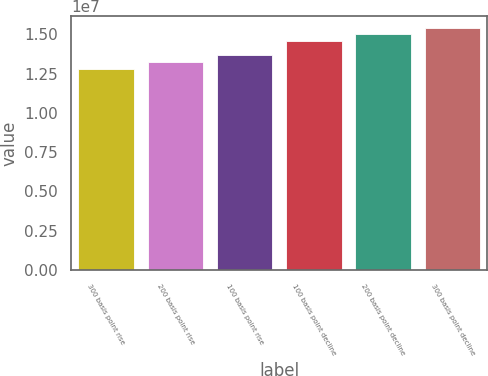<chart> <loc_0><loc_0><loc_500><loc_500><bar_chart><fcel>300 basis point rise<fcel>200 basis point rise<fcel>100 basis point rise<fcel>100 basis point decline<fcel>200 basis point decline<fcel>300 basis point decline<nl><fcel>1.27794e+07<fcel>1.32152e+07<fcel>1.36572e+07<fcel>1.45636e+07<fcel>1.4989e+07<fcel>1.54003e+07<nl></chart> 